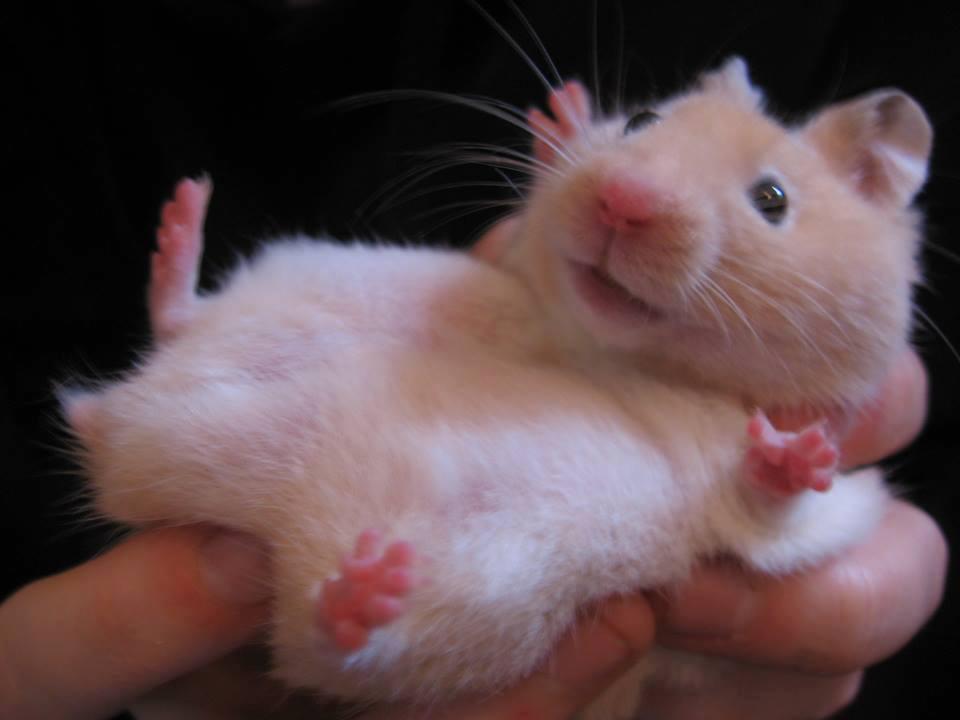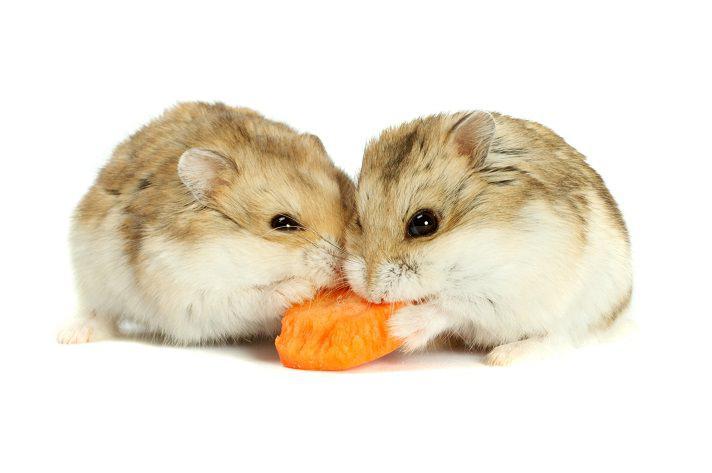The first image is the image on the left, the second image is the image on the right. Evaluate the accuracy of this statement regarding the images: "Two rodents in one of the images are face to face.". Is it true? Answer yes or no. Yes. The first image is the image on the left, the second image is the image on the right. For the images shown, is this caption "An image shows exactly one pet rodent nibbling on a greenish tinged produce item." true? Answer yes or no. No. 